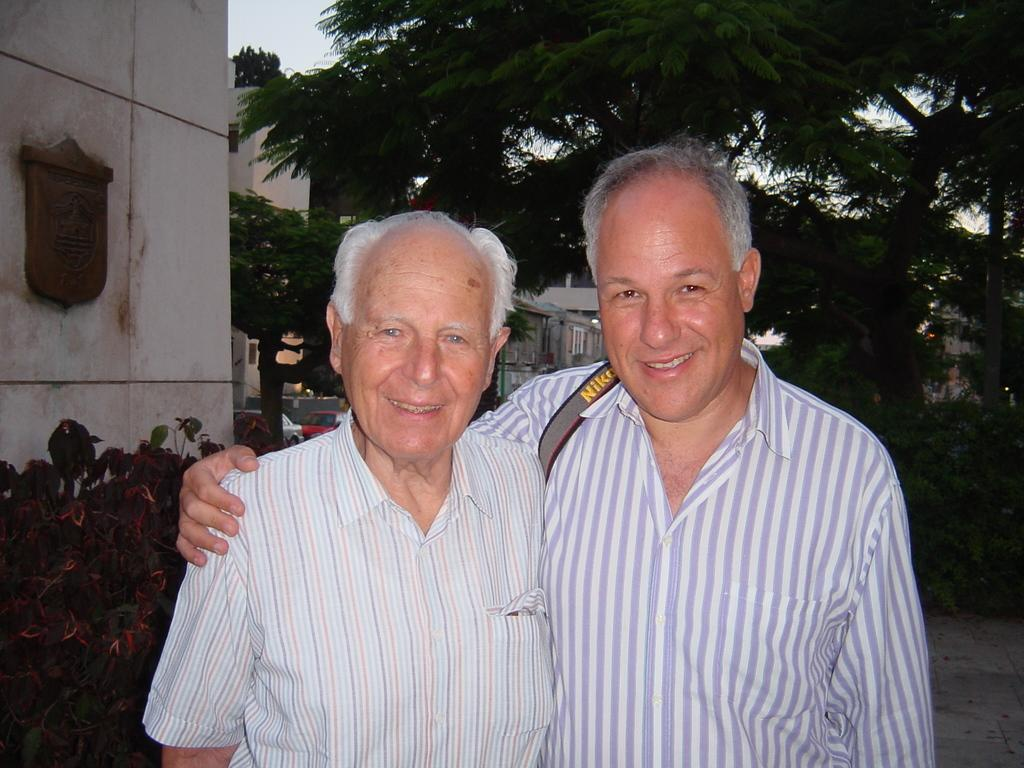<image>
Relay a brief, clear account of the picture shown. A man has a grey strap with NIKO over his shoulder. 